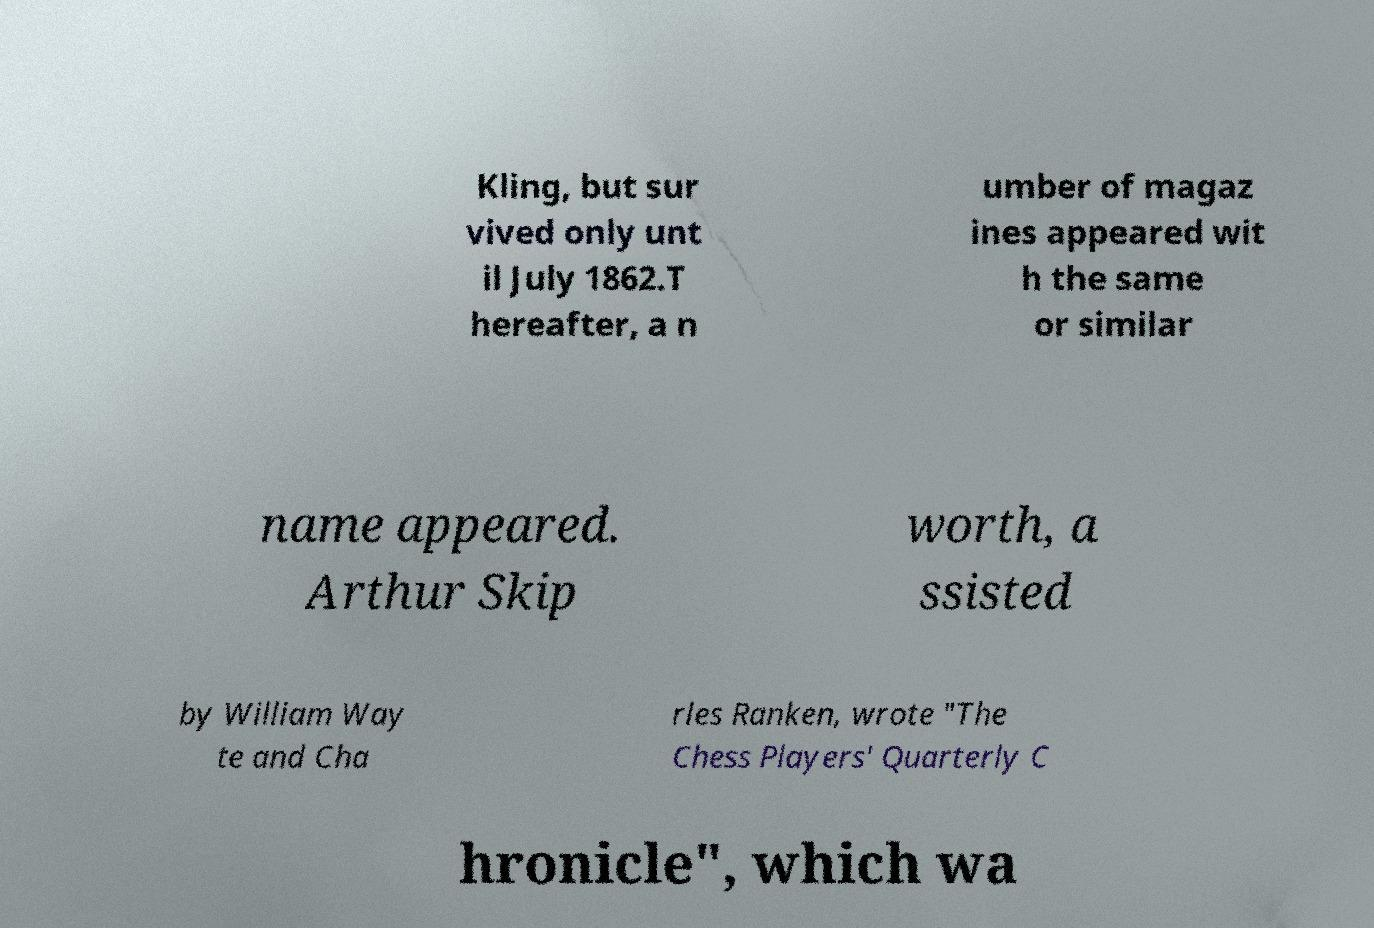What messages or text are displayed in this image? I need them in a readable, typed format. Kling, but sur vived only unt il July 1862.T hereafter, a n umber of magaz ines appeared wit h the same or similar name appeared. Arthur Skip worth, a ssisted by William Way te and Cha rles Ranken, wrote "The Chess Players' Quarterly C hronicle", which wa 